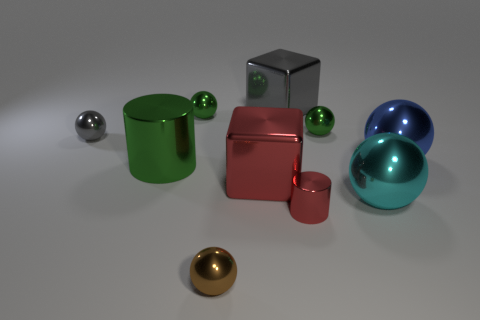Subtract 1 balls. How many balls are left? 5 Subtract all brown balls. How many balls are left? 5 Subtract all small brown metallic spheres. How many spheres are left? 5 Subtract all red balls. Subtract all purple cubes. How many balls are left? 6 Subtract all balls. How many objects are left? 4 Add 6 large spheres. How many large spheres are left? 8 Add 4 gray metal balls. How many gray metal balls exist? 5 Subtract 1 red cubes. How many objects are left? 9 Subtract all tiny gray balls. Subtract all big blue objects. How many objects are left? 8 